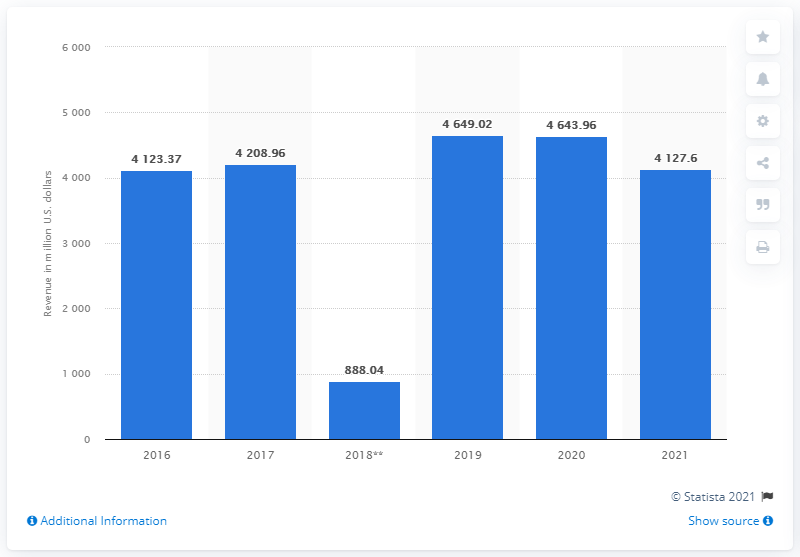Outline some significant characteristics in this image. In 2021, the outdoor segment of VF Corporation generated revenues of approximately $4,127.6 million. 